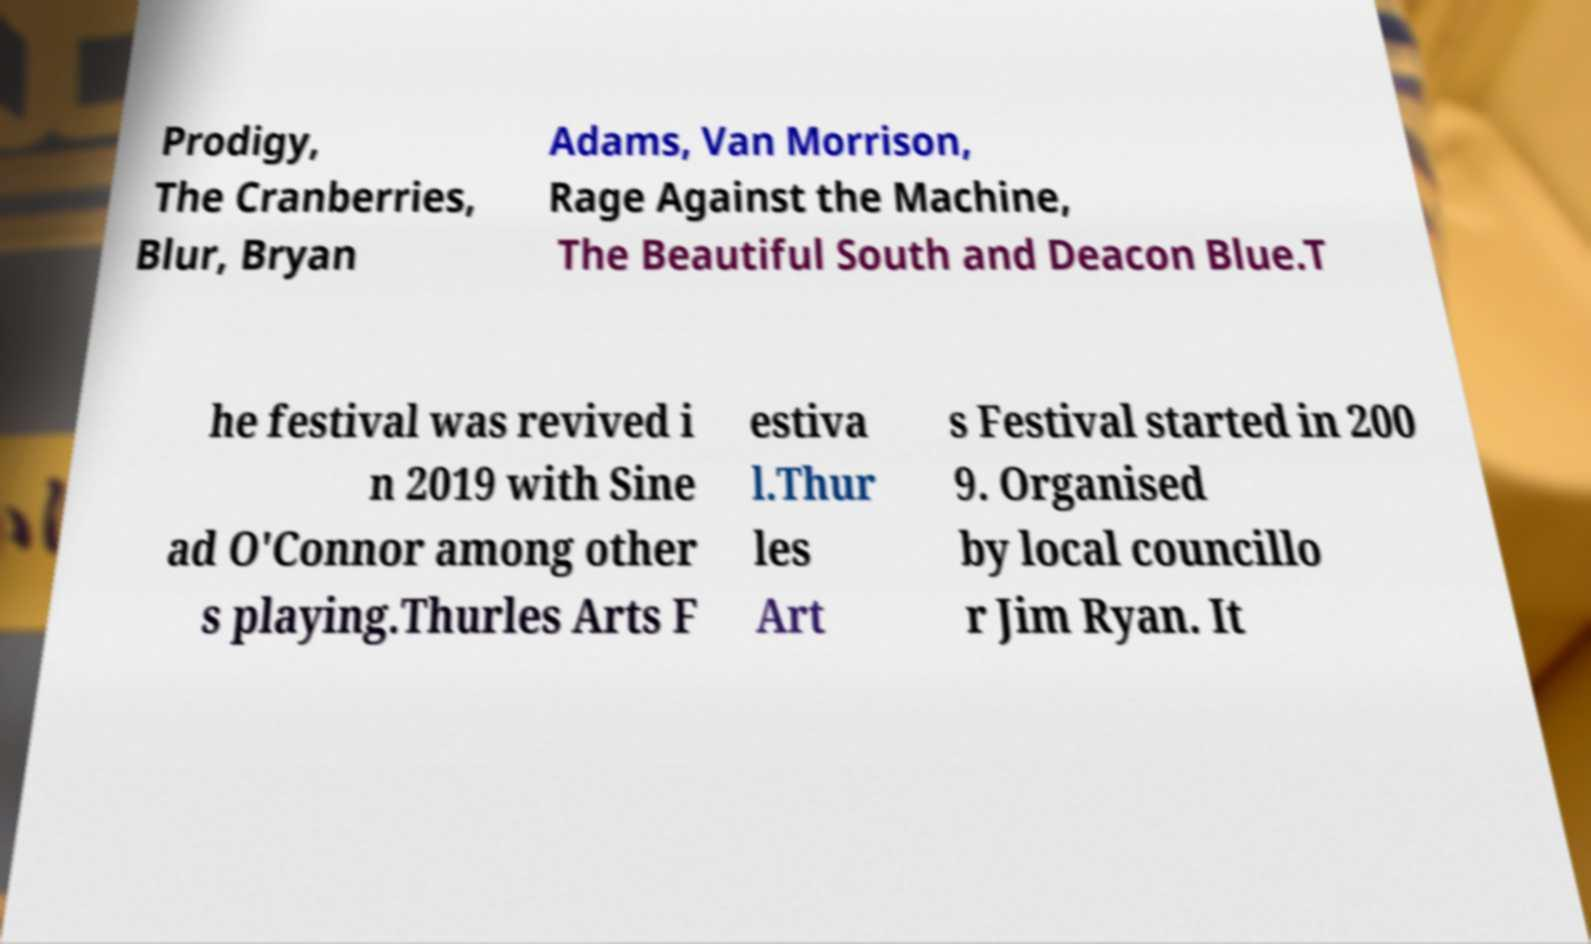Could you extract and type out the text from this image? Prodigy, The Cranberries, Blur, Bryan Adams, Van Morrison, Rage Against the Machine, The Beautiful South and Deacon Blue.T he festival was revived i n 2019 with Sine ad O'Connor among other s playing.Thurles Arts F estiva l.Thur les Art s Festival started in 200 9. Organised by local councillo r Jim Ryan. It 